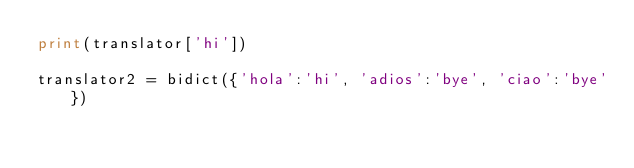<code> <loc_0><loc_0><loc_500><loc_500><_Python_>print(translator['hi'])

translator2 = bidict({'hola':'hi', 'adios':'bye', 'ciao':'bye'})</code> 